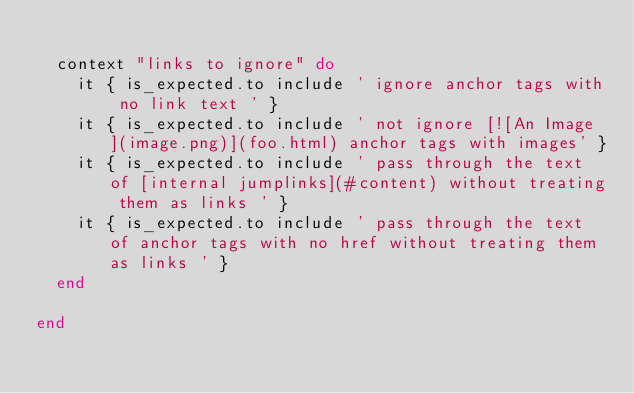<code> <loc_0><loc_0><loc_500><loc_500><_Ruby_>
  context "links to ignore" do
    it { is_expected.to include ' ignore anchor tags with no link text ' }
    it { is_expected.to include ' not ignore [![An Image](image.png)](foo.html) anchor tags with images' }
    it { is_expected.to include ' pass through the text of [internal jumplinks](#content) without treating them as links ' }
    it { is_expected.to include ' pass through the text of anchor tags with no href without treating them as links ' }
  end

end
</code> 